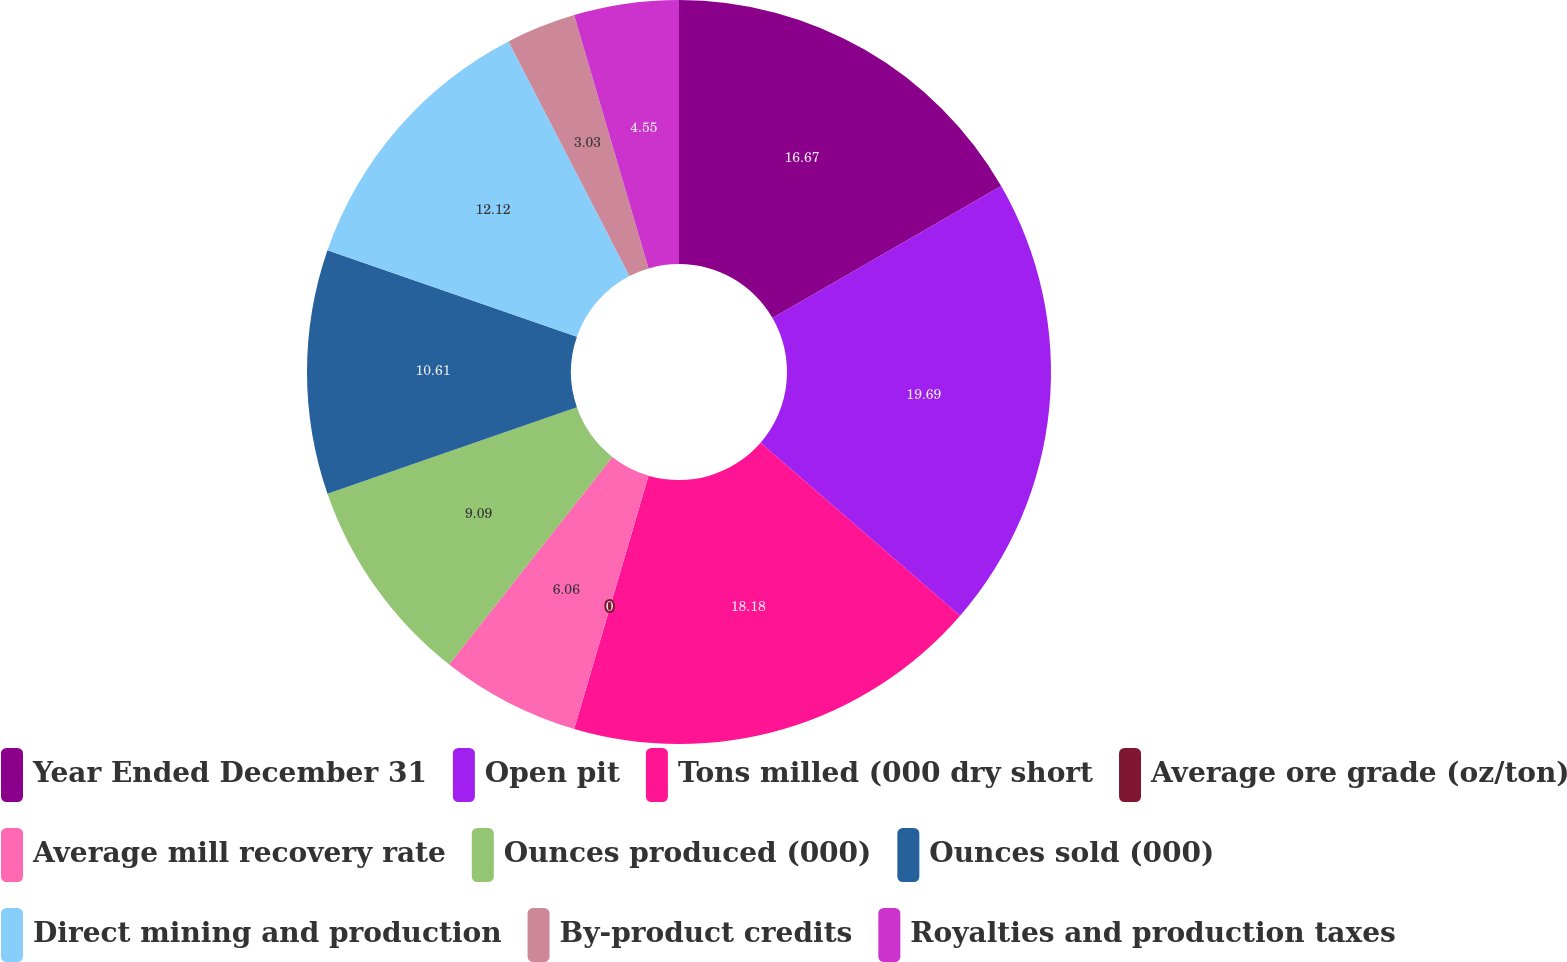<chart> <loc_0><loc_0><loc_500><loc_500><pie_chart><fcel>Year Ended December 31<fcel>Open pit<fcel>Tons milled (000 dry short<fcel>Average ore grade (oz/ton)<fcel>Average mill recovery rate<fcel>Ounces produced (000)<fcel>Ounces sold (000)<fcel>Direct mining and production<fcel>By-product credits<fcel>Royalties and production taxes<nl><fcel>16.67%<fcel>19.7%<fcel>18.18%<fcel>0.0%<fcel>6.06%<fcel>9.09%<fcel>10.61%<fcel>12.12%<fcel>3.03%<fcel>4.55%<nl></chart> 